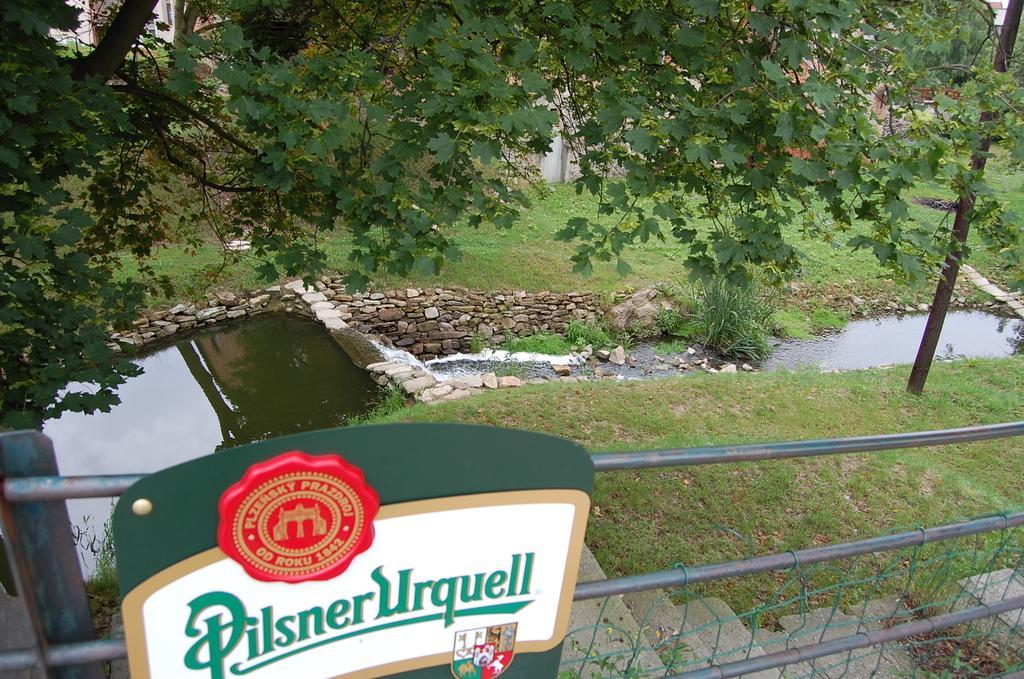Can you describe this image briefly? In this image there is a small pond, water, few stones, a sign board, a fence, a building, there are trees, grass and a pole. 